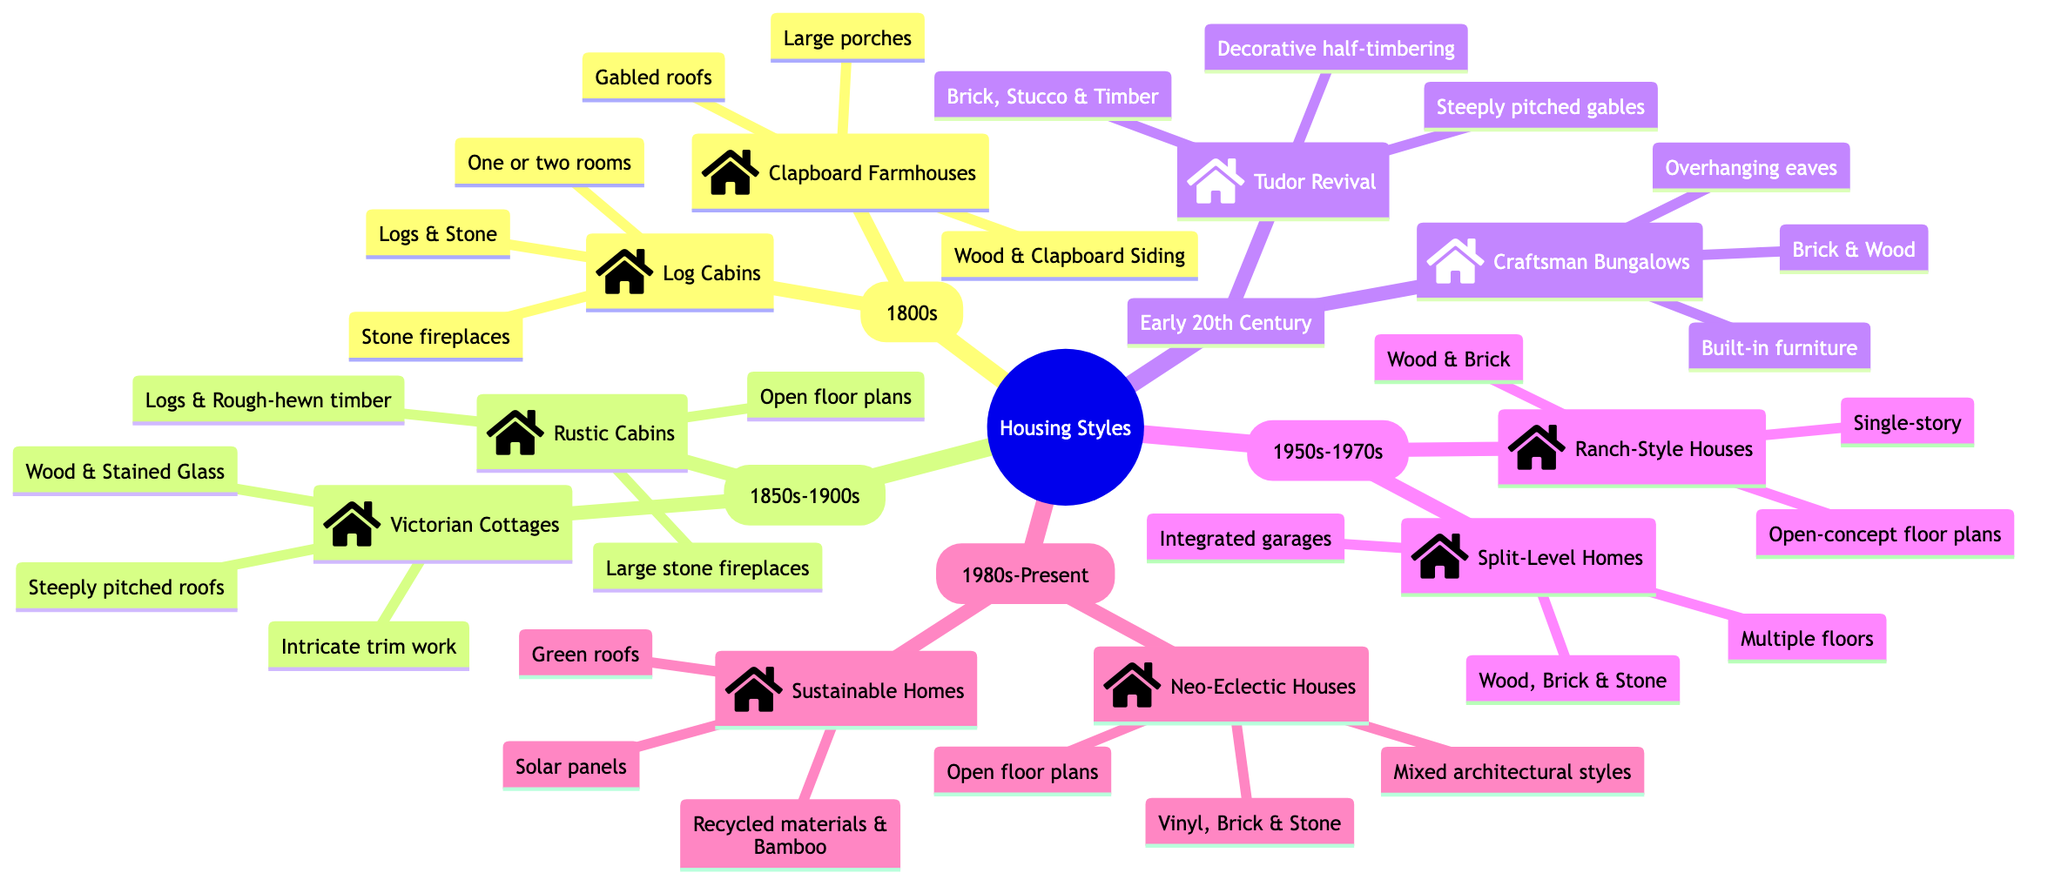What are two housing styles from the Early Settler Era? The Early Settler Era contains two housing styles: Log Cabins and Clapboard Farmhouses. By identifying the children of the “Early Settler Era” node, we can directly list these styles.
Answer: Log Cabins, Clapboard Farmhouses How many styles of housing are listed in the Gold Rush Era? The Gold Rush Era features two distinct styles of housing: Victorian Cottages and Rustic Cabins. Counting the children of the "Gold Rush Era" node confirms this.
Answer: 2 What material is primarily used in Craftsman Bungalows? The Craftsman Bungalows are primarily constructed with Brick and Wood. Observing the details under the "Craftsman Bungalows" node reveals these materials.
Answer: Brick, Wood Name a feature common to Neo-Eclectic Houses. A feature common to Neo-Eclectic Houses is that they have Open floor plans. By checking the "details" section under the "Neo-Eclectic Houses" node, this feature is explicitly stated.
Answer: Open floor plans Which housing style is characterized by steeply pitched roofs? Victorian Cottages are characterized by steeply pitched roofs. This characteristic is part of the features listed under the "Victorian Cottages" node within the Gold Rush Era.
Answer: Victorian Cottages List the two housing styles from the Contemporary Era. The Contemporary Era consists of Neo-Eclectic Houses and Sustainable Homes. By looking at the children of the "Contemporary Era" node, these styles are easily identified.
Answer: Neo-Eclectic Houses, Sustainable Homes What is a significant feature of Rustic Cabins? A significant feature of Rustic Cabins is the Open floor plans. This is explicitly mentioned in the details for Rustic Cabins under the Gold Rush Era.
Answer: Open floor plans How does the Tudor Revival differ from the Craftsman Bungalows in terms of materials? The Tudor Revival uses Brick, Stucco, and Timber while the Craftsman Bungalows use Brick and Wood. Comparing the materials listed under both the "Tudor Revival" and "Craftsman Bungalows" nodes highlights this difference.
Answer: Brick, Stucco, Timber; Brick, Wood What era features Split-Level Homes? Split-Level Homes are featured in the Mid-Century Modern era (1950s-1970s). This can be verified by locating the "Split-Level Homes" node within its corresponding temporal category.
Answer: Mid-Century Modern (1950s-1970s) 